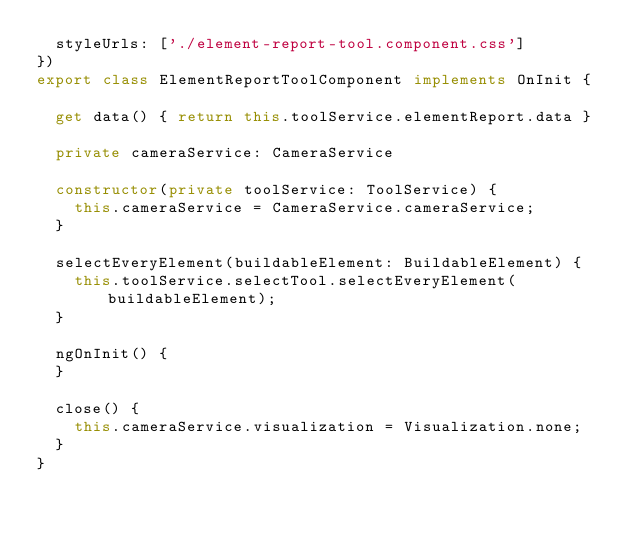<code> <loc_0><loc_0><loc_500><loc_500><_TypeScript_>  styleUrls: ['./element-report-tool.component.css']
})
export class ElementReportToolComponent implements OnInit {

  get data() { return this.toolService.elementReport.data }

  private cameraService: CameraService

  constructor(private toolService: ToolService) {
    this.cameraService = CameraService.cameraService;
  }

  selectEveryElement(buildableElement: BuildableElement) {
    this.toolService.selectTool.selectEveryElement(buildableElement);
  }

  ngOnInit() {
  }

  close() {
    this.cameraService.visualization = Visualization.none;
  }
}
</code> 